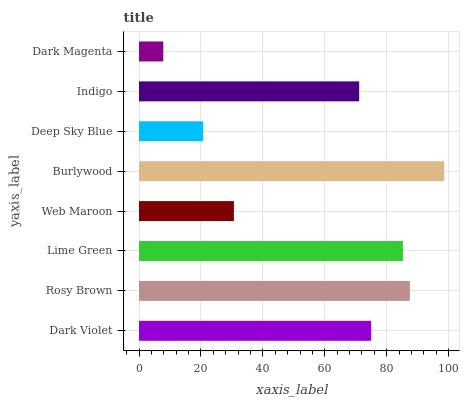Is Dark Magenta the minimum?
Answer yes or no. Yes. Is Burlywood the maximum?
Answer yes or no. Yes. Is Rosy Brown the minimum?
Answer yes or no. No. Is Rosy Brown the maximum?
Answer yes or no. No. Is Rosy Brown greater than Dark Violet?
Answer yes or no. Yes. Is Dark Violet less than Rosy Brown?
Answer yes or no. Yes. Is Dark Violet greater than Rosy Brown?
Answer yes or no. No. Is Rosy Brown less than Dark Violet?
Answer yes or no. No. Is Dark Violet the high median?
Answer yes or no. Yes. Is Indigo the low median?
Answer yes or no. Yes. Is Deep Sky Blue the high median?
Answer yes or no. No. Is Dark Magenta the low median?
Answer yes or no. No. 